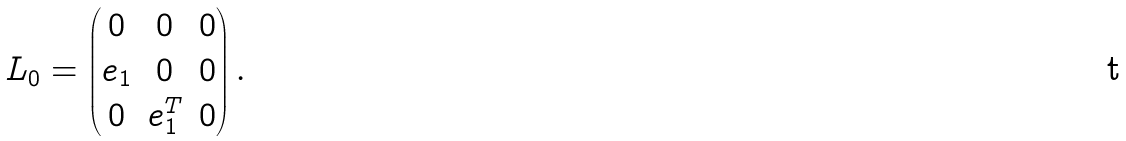<formula> <loc_0><loc_0><loc_500><loc_500>L _ { 0 } = \begin{pmatrix} 0 & 0 & 0 \\ e _ { 1 } & 0 & 0 \\ 0 & e _ { 1 } ^ { T } & 0 \end{pmatrix} .</formula> 